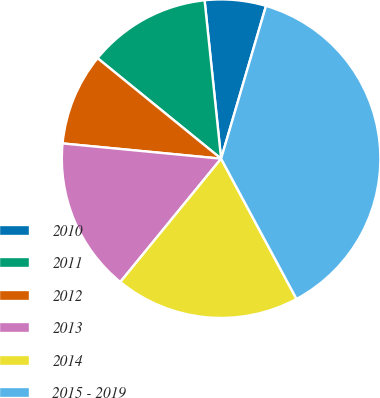Convert chart. <chart><loc_0><loc_0><loc_500><loc_500><pie_chart><fcel>2010<fcel>2011<fcel>2012<fcel>2013<fcel>2014<fcel>2015 - 2019<nl><fcel>6.2%<fcel>12.48%<fcel>9.34%<fcel>15.62%<fcel>18.76%<fcel>37.6%<nl></chart> 